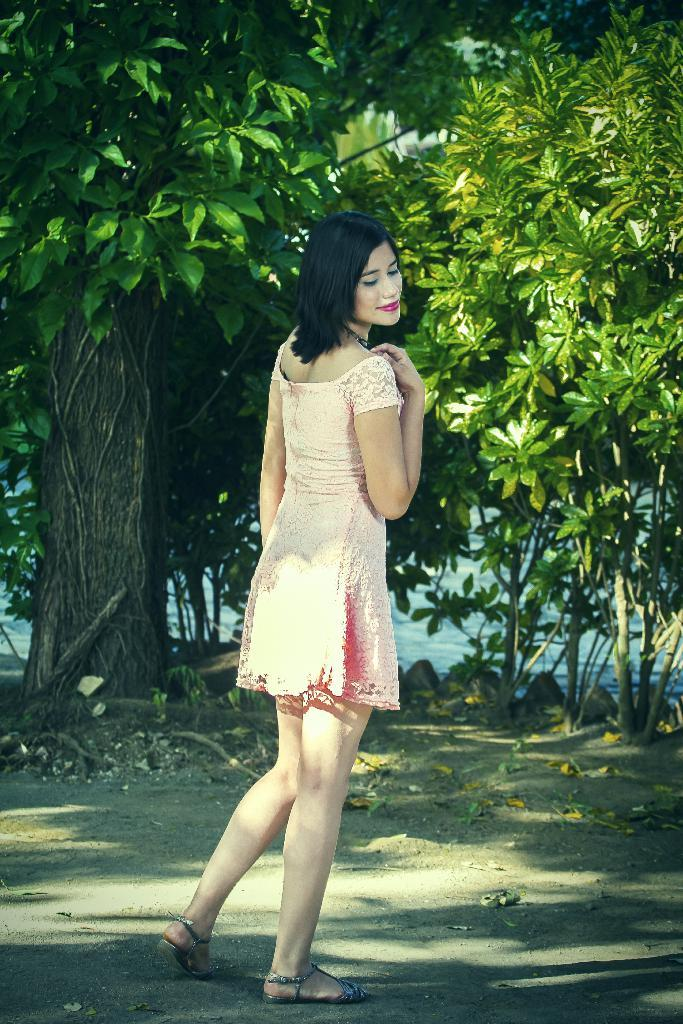Who is the main subject in the image? There is a woman in the image. What is the woman wearing? The woman is wearing a frock. Where is the woman located in the image? The woman is standing on the road. What expression does the woman have? The woman is smiling. What is the woman doing in the image? The woman is giving a pose for the picture. What can be seen in the background of the image? There are trees in the background of the image. What type of punishment is the woman receiving in the image? There is no indication in the image that the woman is receiving any punishment; she is smiling and posing for the picture. What memories does the woman have of the event in the image? There is no information about the woman's memories or any event in the image. 